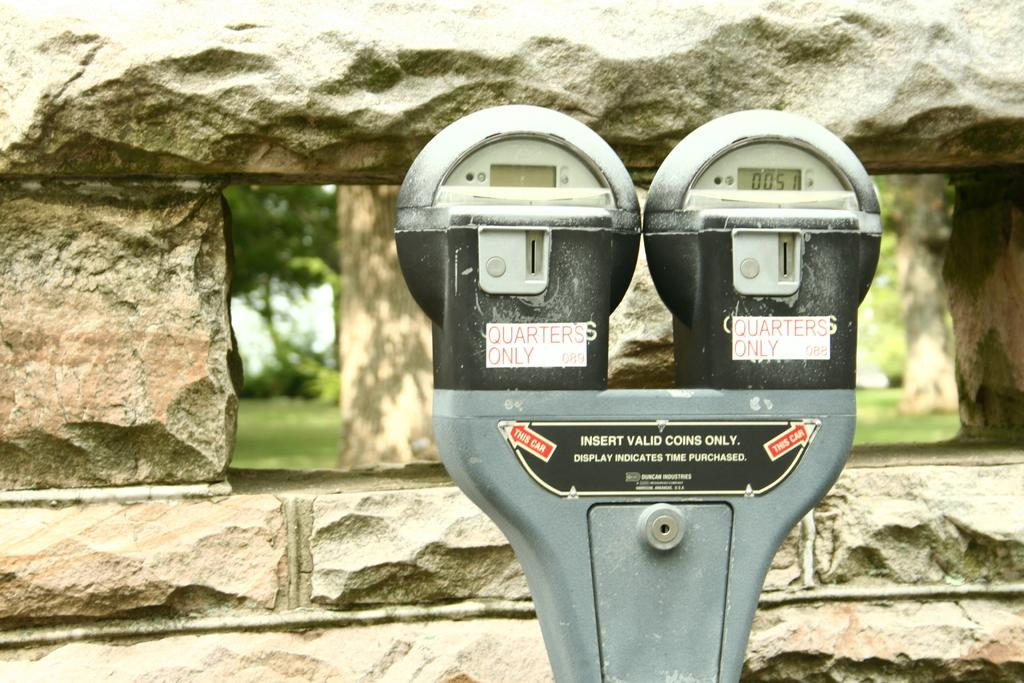Provide a one-sentence caption for the provided image. a dual parking meter that reads Quarters Only. 